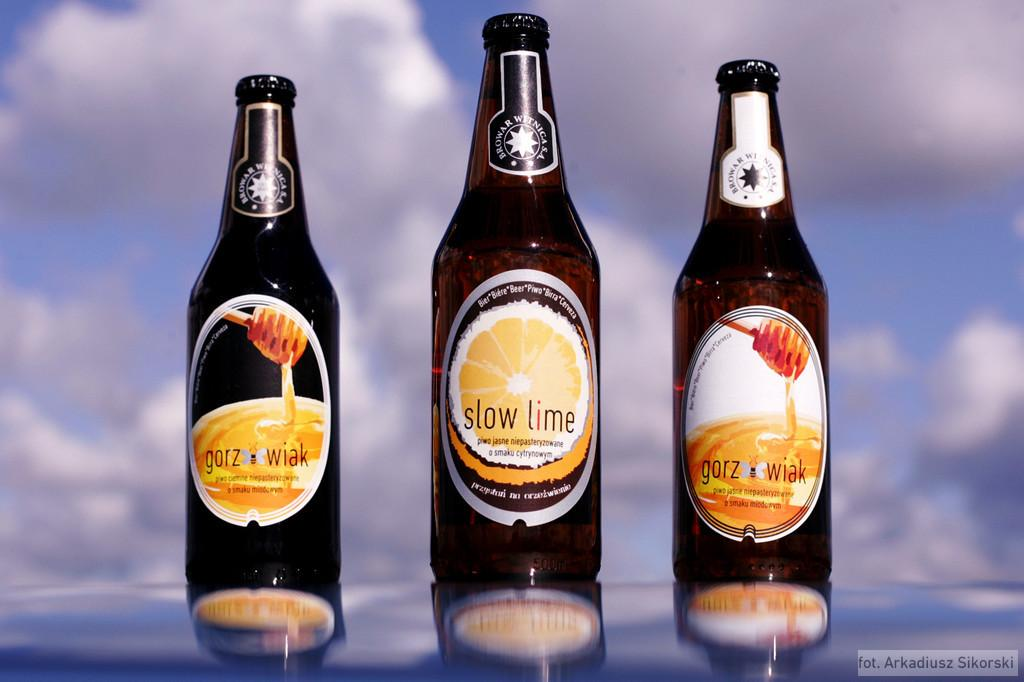<image>
Describe the image concisely. Three bottles of beer brewed by Browar Witnica in honey and lime flavors. 